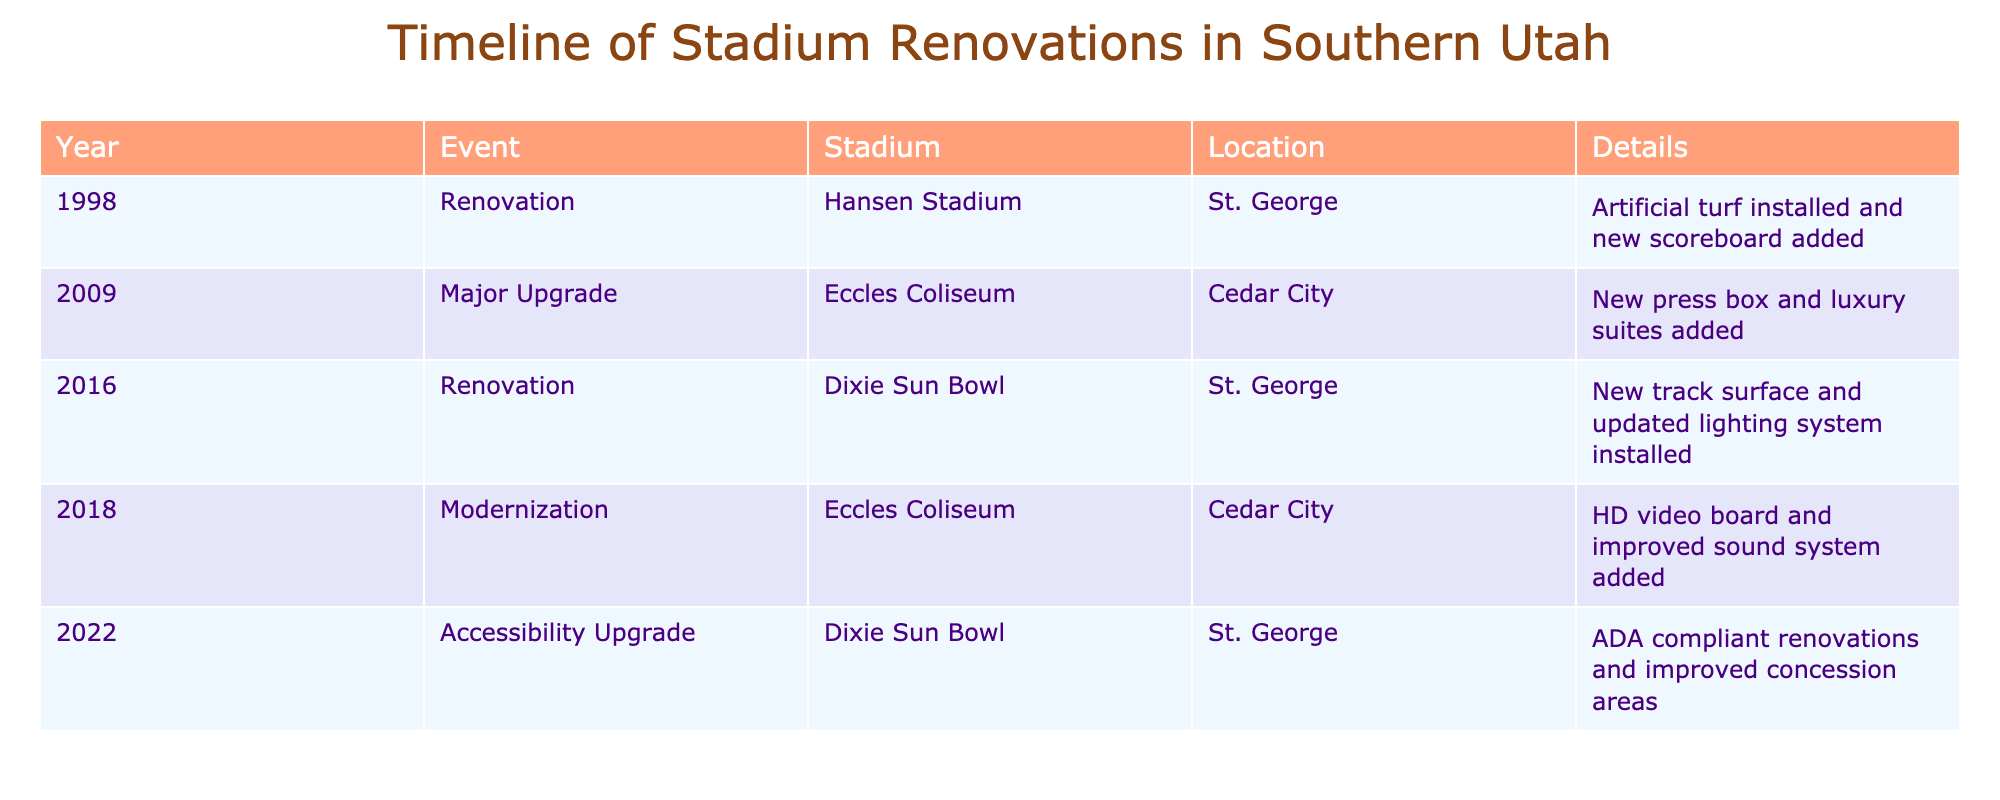What year did Hansen Stadium undergo renovation? The table shows the year and event for Hansen Stadium. By looking under the Year column for Hansen Stadium, the data indicates a renovation occurred in 1998.
Answer: 1998 How many stadiums had upgrades in 2018? The table has two rows with the year 2018 listed; however, the only stadium listed with a major modernization event is Eccles Coliseum. Therefore, only one stadium had upgrades in that year.
Answer: 1 Was there a major upgrade to Dixie Sun Bowl? The table lists Dixie Sun Bowl, but it shows it received an accessibility upgrade in 2022 and a renovation in 2016, not a major upgrade. Therefore, the fact is false.
Answer: No What renovations occurred in both 2016 and 2022? In 2016, Dixie Sun Bowl had a renovation that included a new track surface and updated lighting. In 2022, it received ADA compliant renovations with improved concession areas. Thus, both years involved renovations to the same stadium.
Answer: Both years involved renovations to Dixie Sun Bowl What is the total number of renovations and upgrades recorded in the table? The table lists five events: two renovations (Hansen Stadium in 1998 and Dixie Sun Bowl in 2016), one major upgrade (Eccles Coliseum in 2009), one modernization (Eccles Coliseum in 2018), and one accessibility upgrade (Dixie Sun Bowl in 2022), making a total of five events.
Answer: 5 